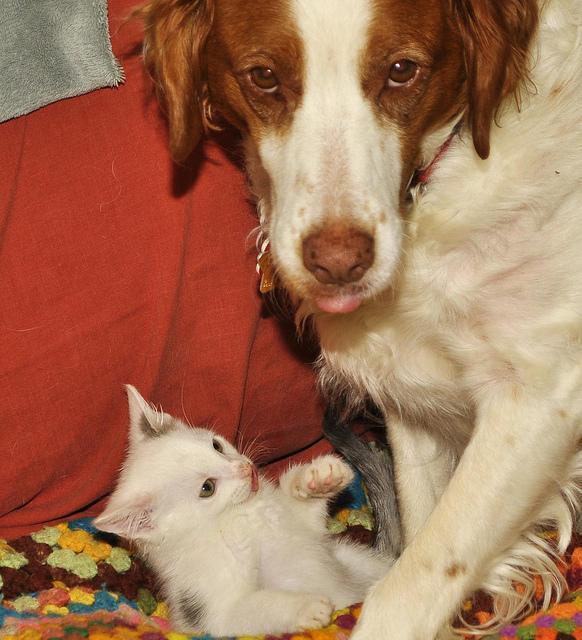How many animals are in this picture?
Give a very brief answer. 2. 